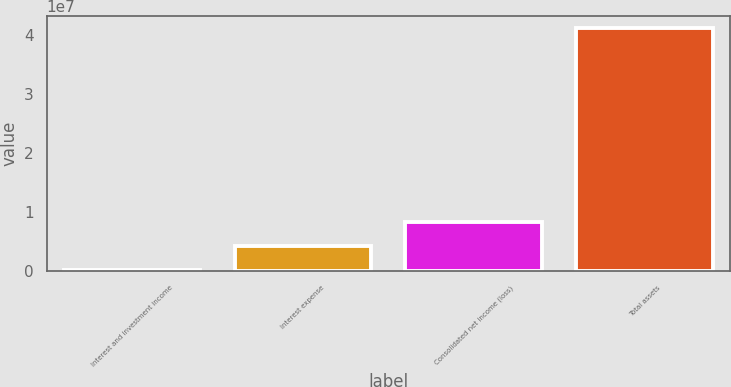Convert chart. <chart><loc_0><loc_0><loc_500><loc_500><bar_chart><fcel>Interest and investment income<fcel>Interest expense<fcel>Consolidated net income (loss)<fcel>Total assets<nl><fcel>189994<fcel>4.28087e+06<fcel>8.37175e+06<fcel>4.10988e+07<nl></chart> 